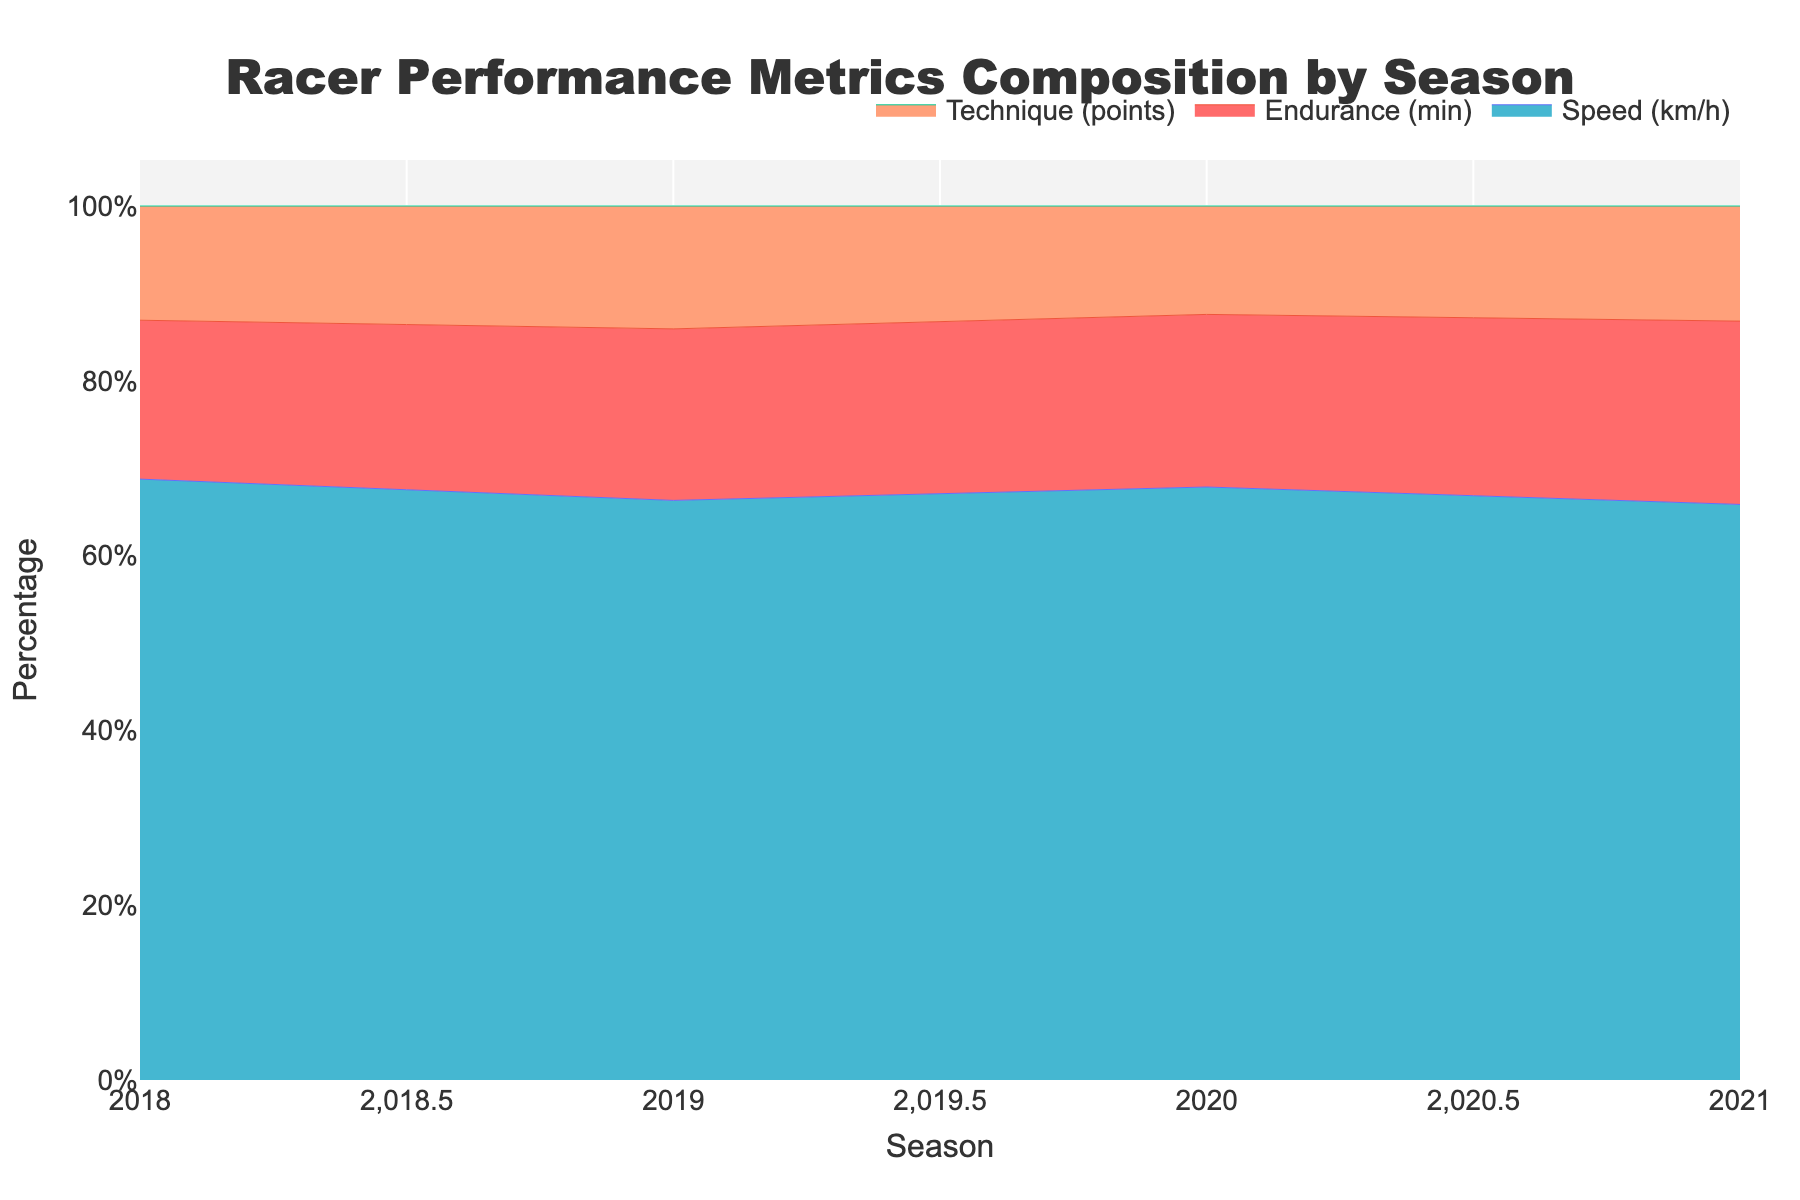What's the title of the figure? The title is located at the top center of the figure.
Answer: Racer Performance Metrics Composition by Season How many seasons are displayed in the figure? Locate the x-axis and count the unique ticks corresponding to each season.
Answer: 4 What metric had the highest percentage composition in 2021? Observe the stacked areas for 2021 and identify the segment with the largest area.
Answer: Endurance Which metric shows the least variability in its percentage composition across the seasons? Compare the height of each stacked area segment across all seasons to determine which remains most consistent.
Answer: Technique How did the composition of Speed change from 2018 to 2021? Assess the change in height of the Speed segment from 2018 to 2021.
Answer: Increased Which season had the highest percentage of Endurance? Identify the tallest Endurance segment across all seasons.
Answer: 2021 What is the combined percentage of Speed and Technique in 2019? Sum the percentages of Speed and Technique segments in 2019.
Answer: ~70% By how much did the percentage of Technique change from 2020 to 2021? Subtract the percentage of Technique in 2020 from its percentage in 2021.
Answer: ~0.6% During which season is the percentage of Speed approximately equal to that of Endurance? Identify the season where the height of Speed and Endurance segments are closest.
Answer: 2019 How does the overall trend of Endurance's composition change from 2018 to 2021? Observe the change in height of the Endurance segment across the seasons.
Answer: Increasing 